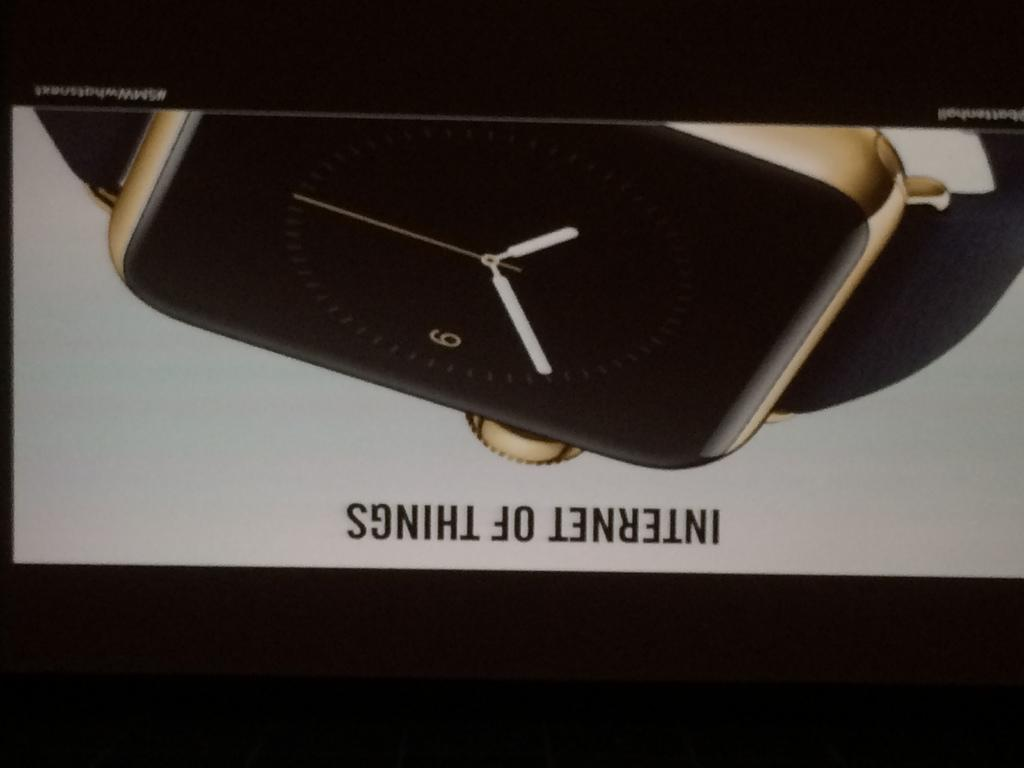What object is present in the image? There is a watch in the image. Can you describe the colors of the watch? The watch is in black and gold color. What type of behavior is exhibited by the volleyball in the image? There is no volleyball present in the image, so it is not possible to determine any behavior. 